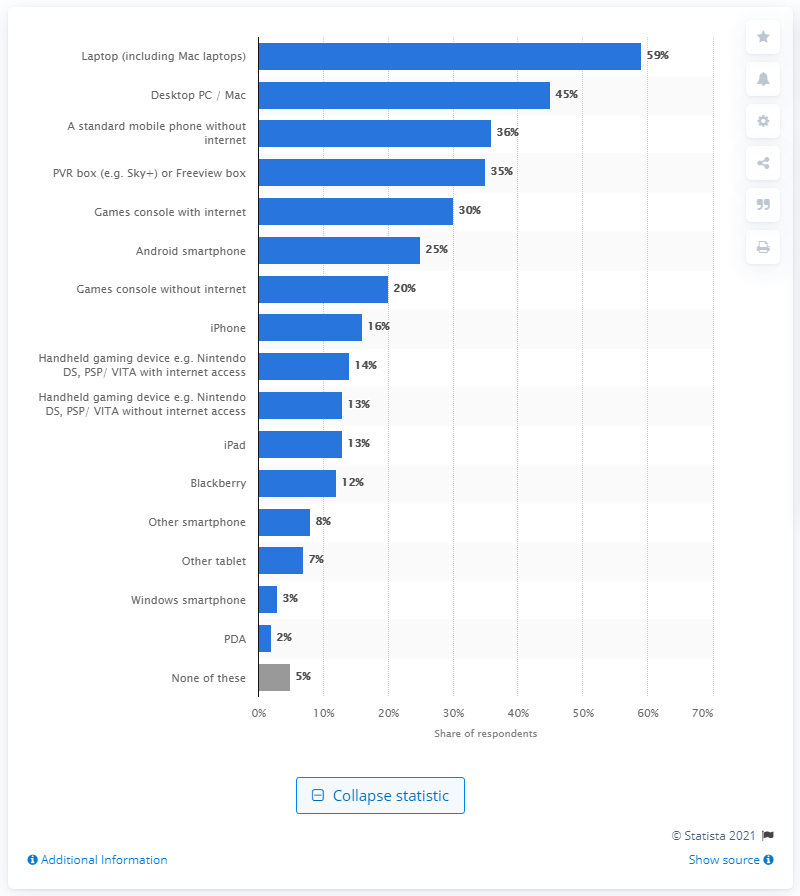Point out several critical features in this image. 45% of respondents reported owning a desktop PC or Mac. 